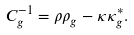<formula> <loc_0><loc_0><loc_500><loc_500>C _ { g } ^ { - 1 } = \rho \rho _ { g } - \kappa \kappa _ { g } ^ { \ast } .</formula> 